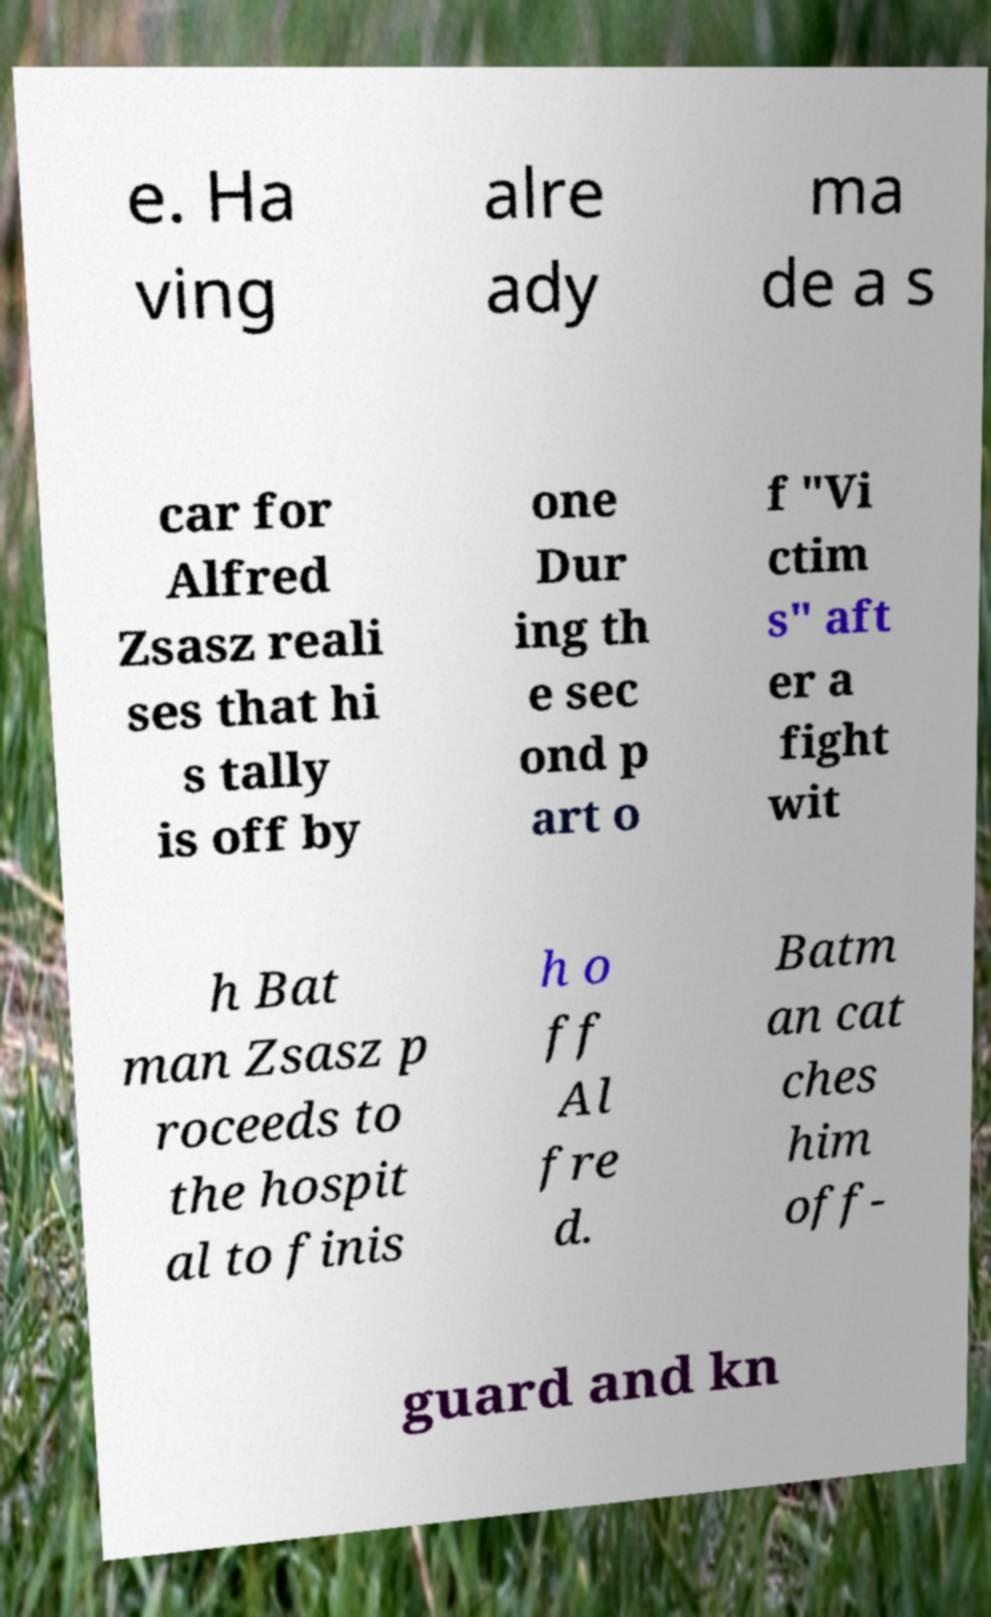Please identify and transcribe the text found in this image. e. Ha ving alre ady ma de a s car for Alfred Zsasz reali ses that hi s tally is off by one Dur ing th e sec ond p art o f "Vi ctim s" aft er a fight wit h Bat man Zsasz p roceeds to the hospit al to finis h o ff Al fre d. Batm an cat ches him off- guard and kn 